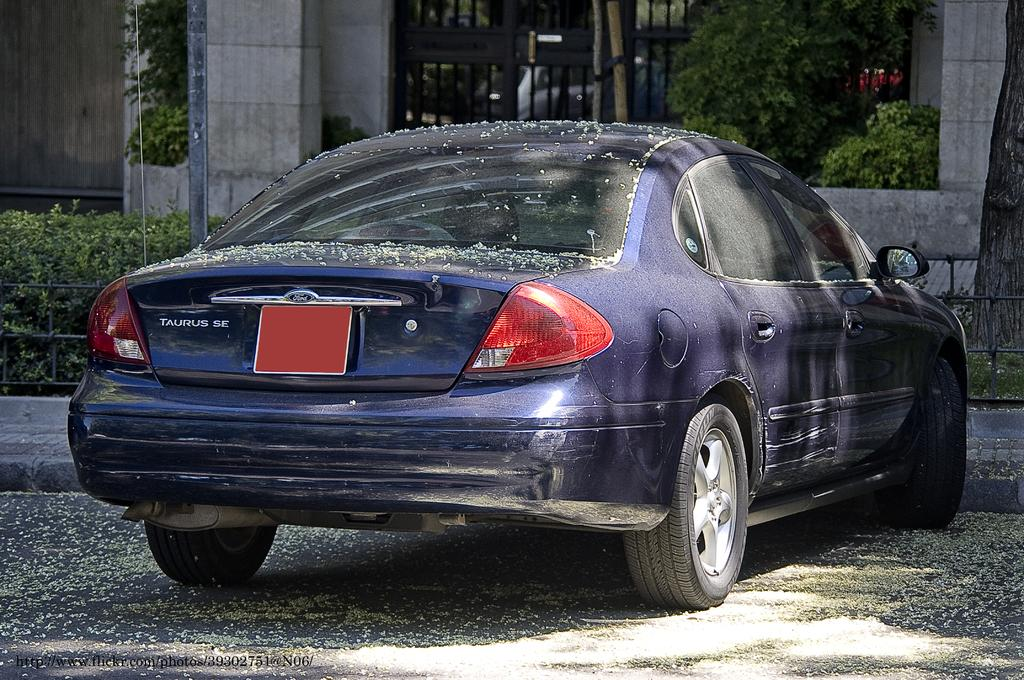What is parked in front of the building in the image? There is a car parked in front of a building in the image. What is on the car? There are dry flowers on the car. What else can be seen in front of the car? There are small plants and a tree in front of the car. What is the opinion of the tree about the car in the image? Trees do not have opinions, so this question cannot be answered. 